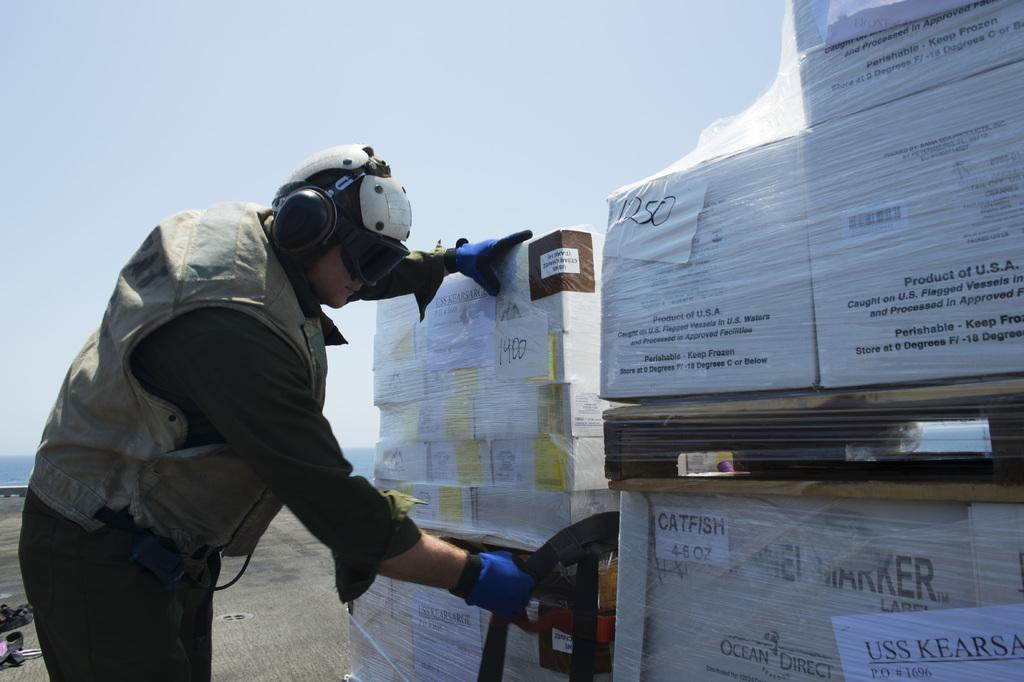Who is present in the image? There is a man in the image. What is the man wearing on his ears? The man is wearing headphones. What type of eyewear is the man wearing? The man is wearing spectacles. What objects are in front of the man? There are boxes in front of the man. What type of flesh can be seen on the man's face in the image? There is no flesh visible on the man's face in the image; it is not possible to see beneath the surface of the skin. 